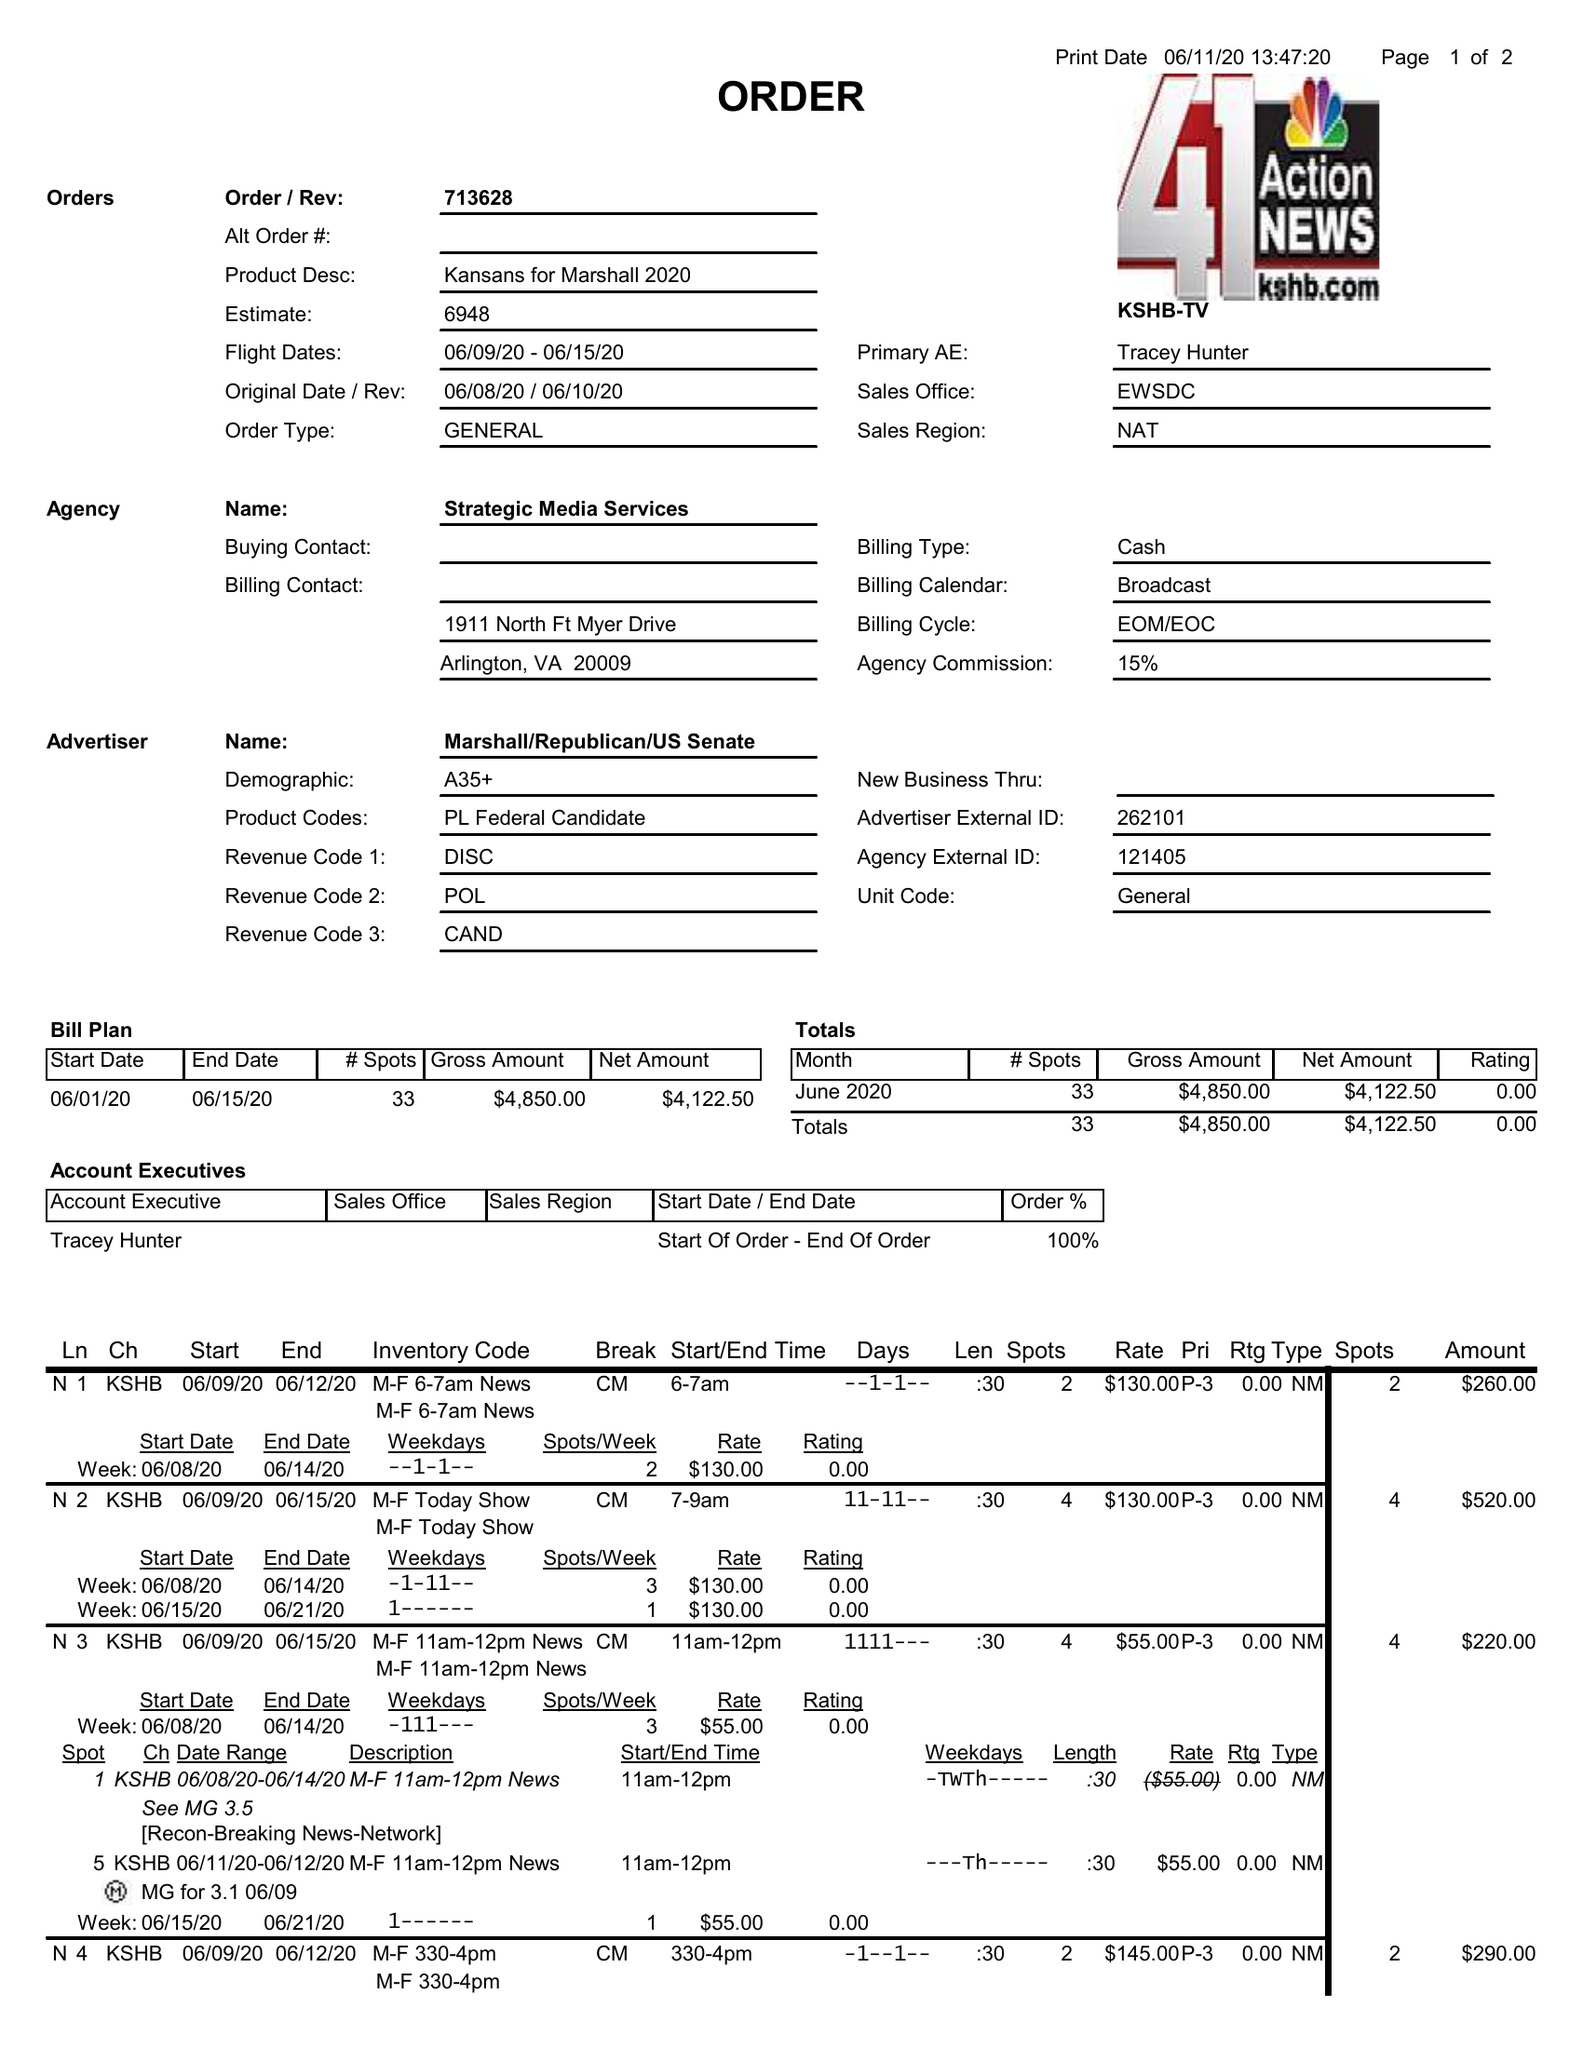What is the value for the flight_to?
Answer the question using a single word or phrase. 06/15/20 